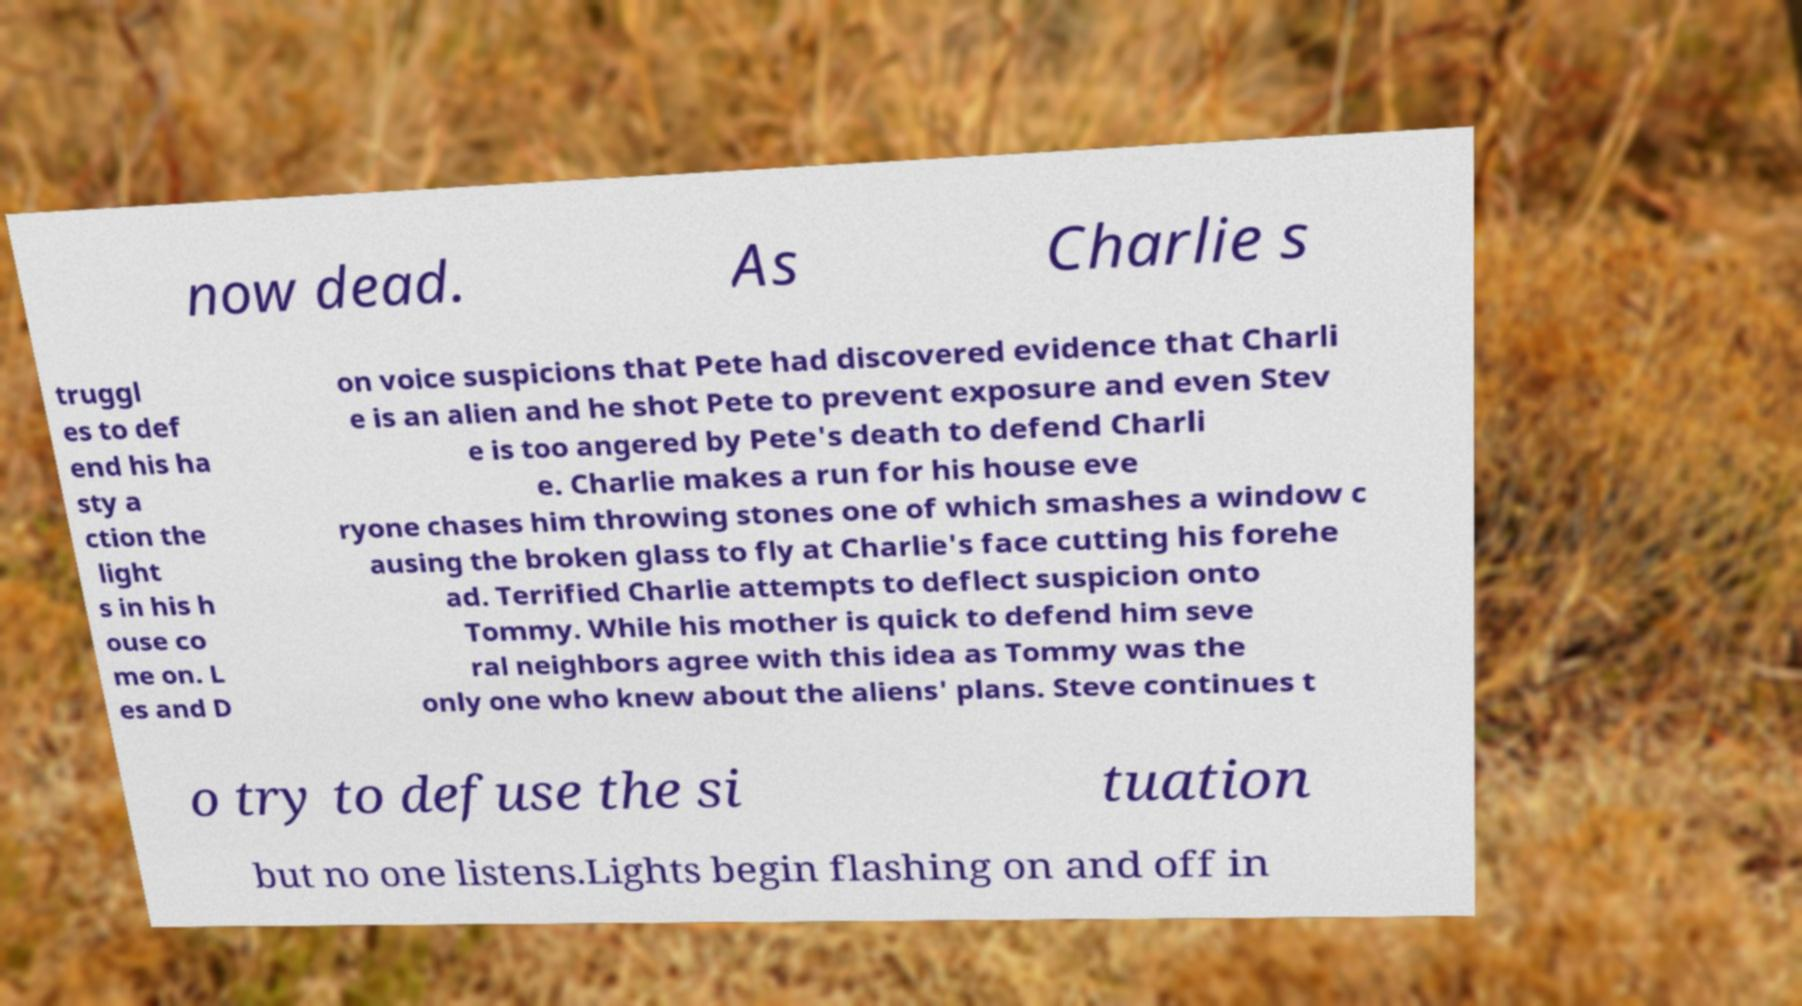Could you assist in decoding the text presented in this image and type it out clearly? now dead. As Charlie s truggl es to def end his ha sty a ction the light s in his h ouse co me on. L es and D on voice suspicions that Pete had discovered evidence that Charli e is an alien and he shot Pete to prevent exposure and even Stev e is too angered by Pete's death to defend Charli e. Charlie makes a run for his house eve ryone chases him throwing stones one of which smashes a window c ausing the broken glass to fly at Charlie's face cutting his forehe ad. Terrified Charlie attempts to deflect suspicion onto Tommy. While his mother is quick to defend him seve ral neighbors agree with this idea as Tommy was the only one who knew about the aliens' plans. Steve continues t o try to defuse the si tuation but no one listens.Lights begin flashing on and off in 